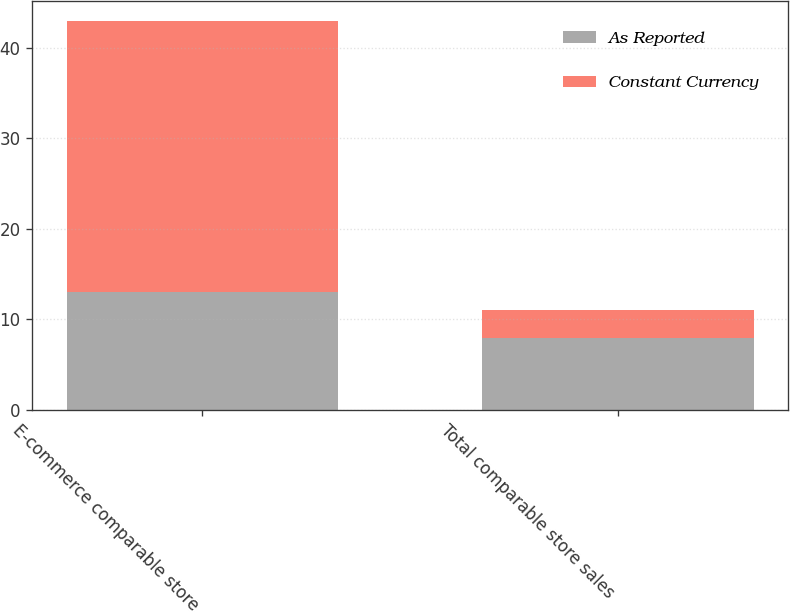Convert chart to OTSL. <chart><loc_0><loc_0><loc_500><loc_500><stacked_bar_chart><ecel><fcel>E-commerce comparable store<fcel>Total comparable store sales<nl><fcel>As Reported<fcel>13<fcel>8<nl><fcel>Constant Currency<fcel>30<fcel>3<nl></chart> 